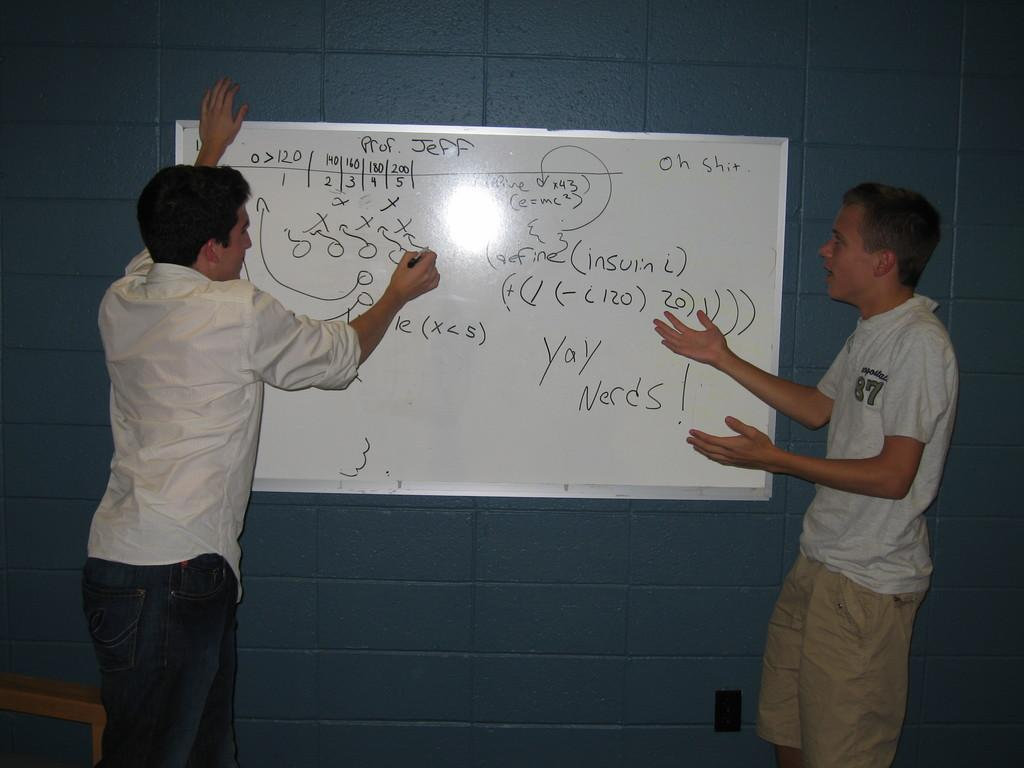How many people are in the image? There are two men in the image. What is one of the men holding? One of the men is holding a sketch. What is the man holding the sketch doing? The man holding the sketch is also writing on a board. Can you describe the board in the image? Yes, there is a board in the image. What is visible behind the board? There is a wall behind the board. What riddle is the father telling in the image? There is no father present in the image, nor is there any indication of a riddle being told. 